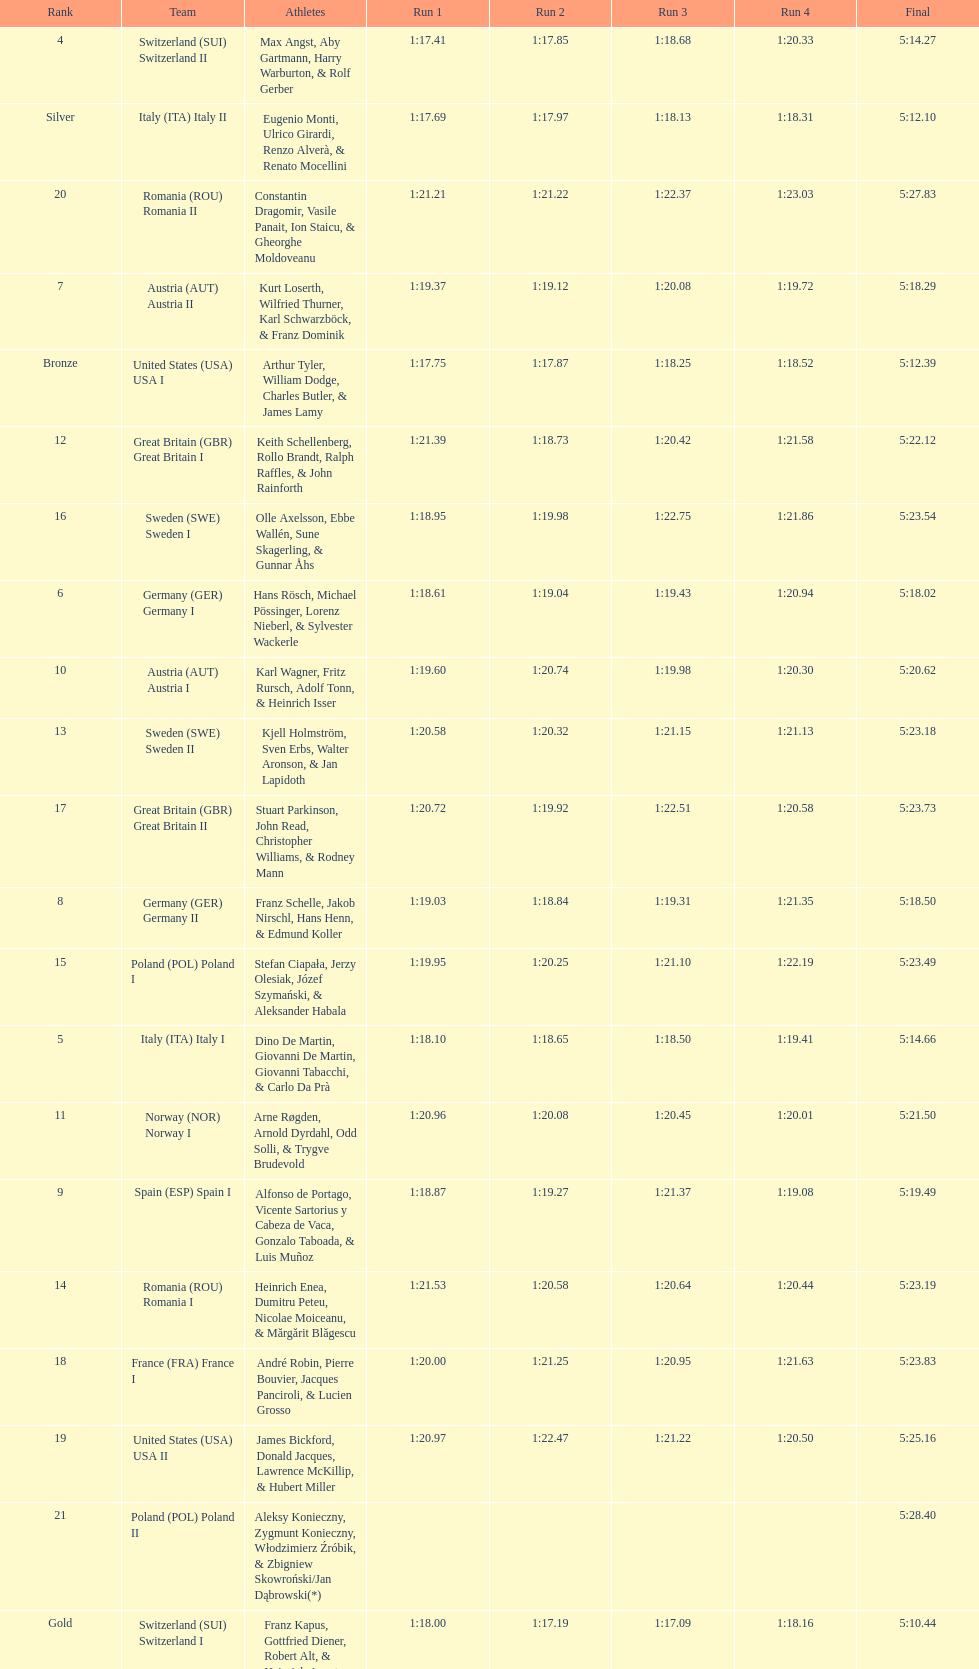Which team had the most time? Poland. 